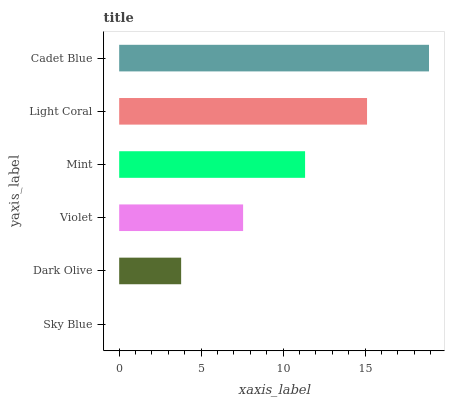Is Sky Blue the minimum?
Answer yes or no. Yes. Is Cadet Blue the maximum?
Answer yes or no. Yes. Is Dark Olive the minimum?
Answer yes or no. No. Is Dark Olive the maximum?
Answer yes or no. No. Is Dark Olive greater than Sky Blue?
Answer yes or no. Yes. Is Sky Blue less than Dark Olive?
Answer yes or no. Yes. Is Sky Blue greater than Dark Olive?
Answer yes or no. No. Is Dark Olive less than Sky Blue?
Answer yes or no. No. Is Mint the high median?
Answer yes or no. Yes. Is Violet the low median?
Answer yes or no. Yes. Is Sky Blue the high median?
Answer yes or no. No. Is Cadet Blue the low median?
Answer yes or no. No. 